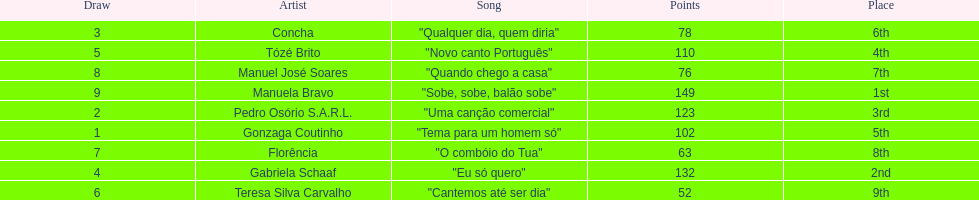Who sang "eu só quero" as their song in the eurovision song contest of 1979? Gabriela Schaaf. 